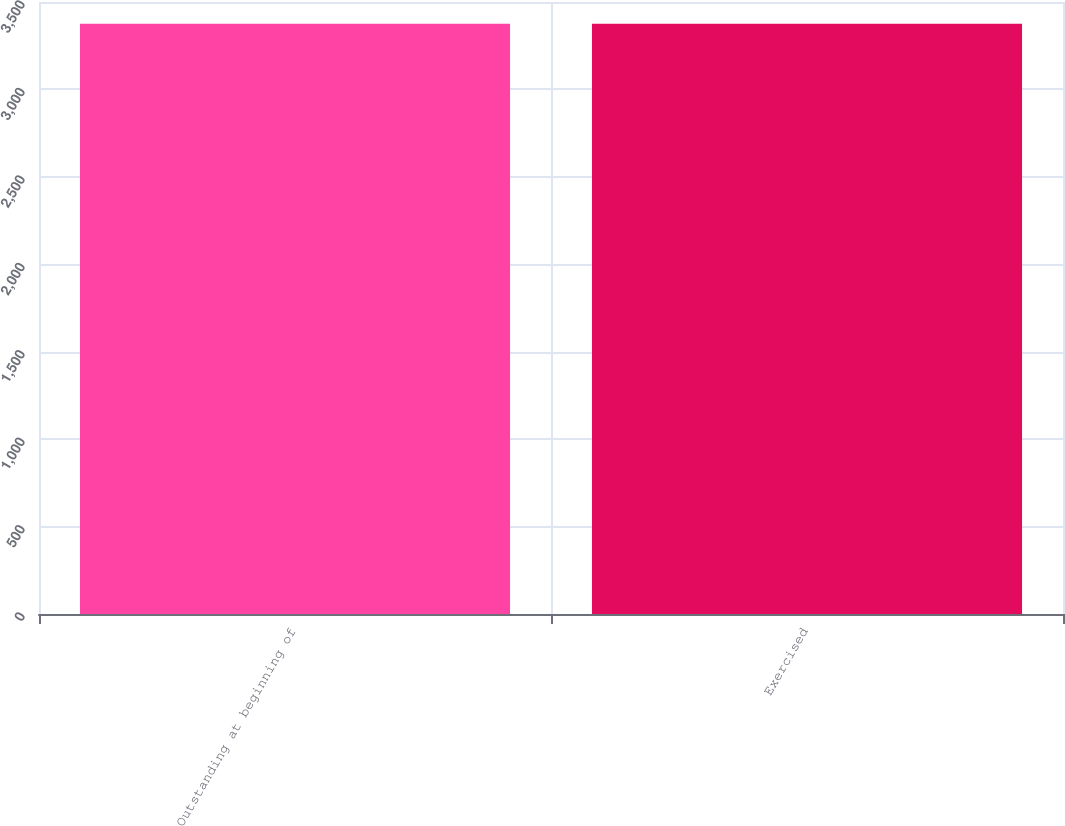Convert chart to OTSL. <chart><loc_0><loc_0><loc_500><loc_500><bar_chart><fcel>Outstanding at beginning of<fcel>Exercised<nl><fcel>3375<fcel>3375.1<nl></chart> 